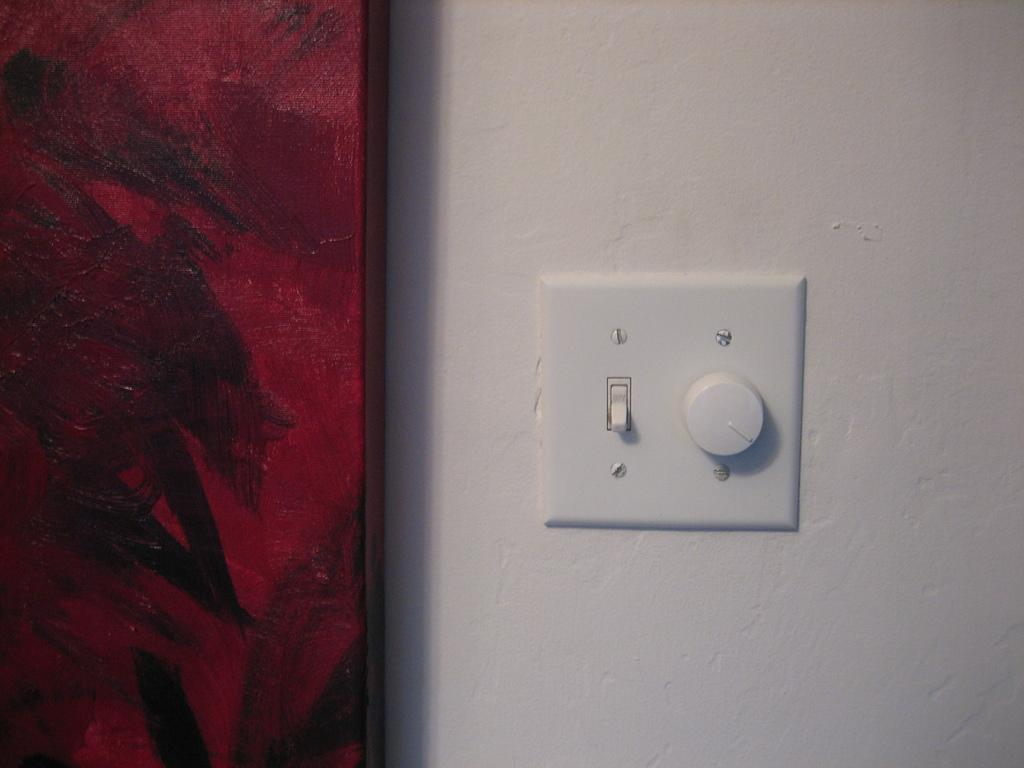What is located on the wall in the image? There is a switch and a ceiling fan regulator on the wall in the image. What can be seen on the left side of the image? There appears to be a cupboard on the left side of the image. How many crows are sitting on the ceiling fan regulator in the image? There are no crows present in the image. What type of alarm is attached to the switch in the image? There is no alarm attached to the switch in the image. 